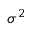<formula> <loc_0><loc_0><loc_500><loc_500>\sigma ^ { 2 }</formula> 